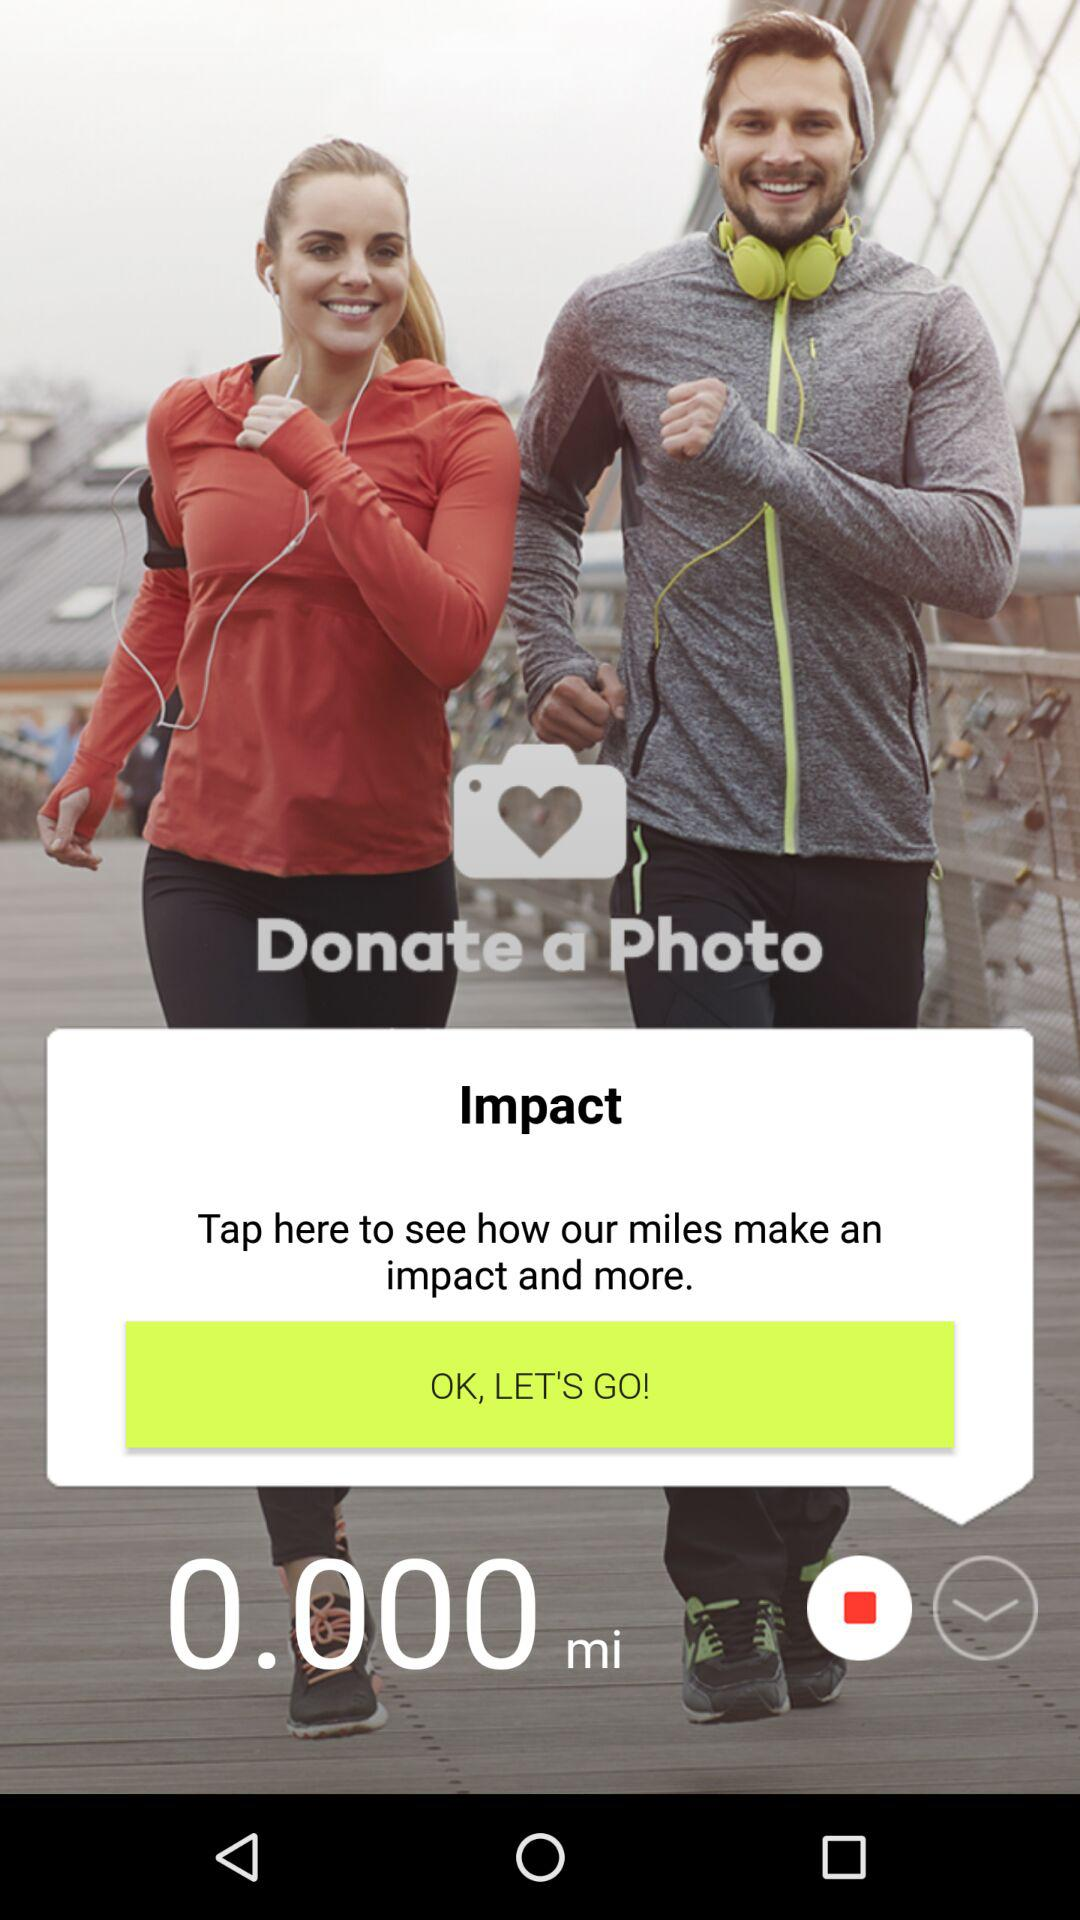What is the application name? The application name is "Donate a Photo". 